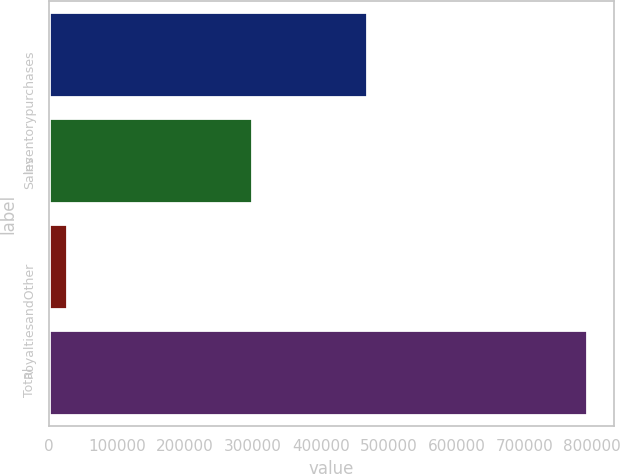Convert chart. <chart><loc_0><loc_0><loc_500><loc_500><bar_chart><fcel>Inventorypurchases<fcel>Sales<fcel>RoyaltiesandOther<fcel>Total<nl><fcel>468305<fcel>298194<fcel>26341<fcel>792840<nl></chart> 